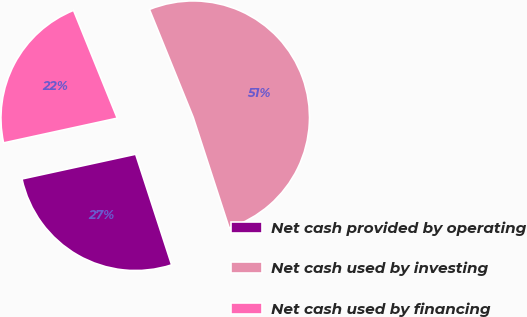Convert chart. <chart><loc_0><loc_0><loc_500><loc_500><pie_chart><fcel>Net cash provided by operating<fcel>Net cash used by investing<fcel>Net cash used by financing<nl><fcel>26.59%<fcel>51.13%<fcel>22.28%<nl></chart> 